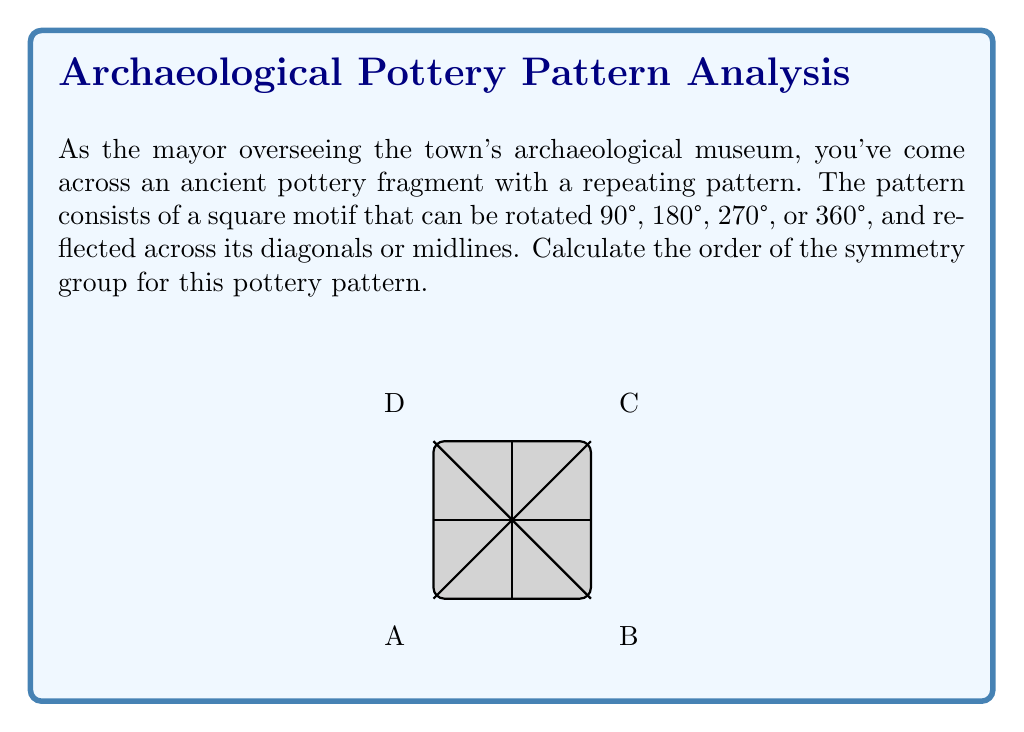Could you help me with this problem? To calculate the order of the symmetry group, we need to identify all the symmetry operations that leave the pattern unchanged:

1. Rotations:
   - Identity (0° or 360°)
   - 90° clockwise
   - 180°
   - 270° clockwise (90° counterclockwise)

2. Reflections:
   - Across diagonal AC
   - Across diagonal BD
   - Across vertical midline
   - Across horizontal midline

Let's count these symmetries:

$$\text{Number of rotations} = 4$$
$$\text{Number of reflections} = 4$$

The total number of symmetry operations is the sum of rotations and reflections:

$$\text{Total symmetries} = 4 + 4 = 8$$

This group of symmetries is known as the dihedral group $D_4$, which has order 8.

To verify this, we can check that these 8 symmetries form a group:
- The set is closed under composition
- The identity element (0° rotation) exists
- Each element has an inverse
- The operation is associative

Therefore, the order of the symmetry group for this pottery pattern is 8.
Answer: 8 